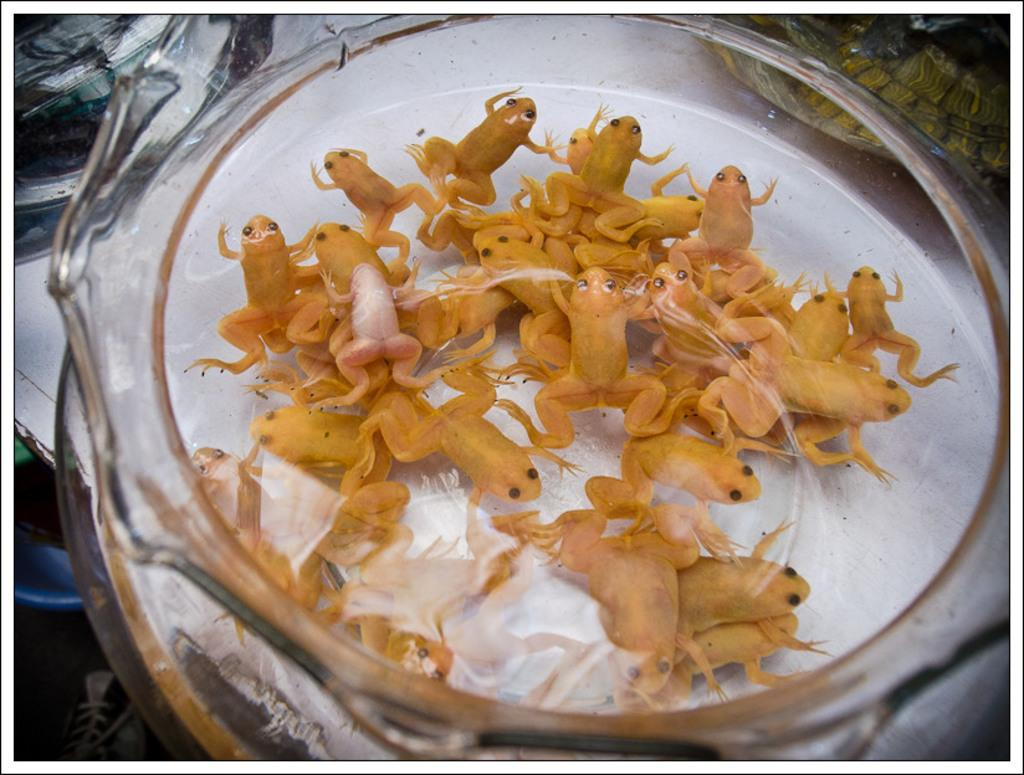What animals are in the glass jar in the image? There are frogs in a glass jar in the image. Where is the glass jar located? The glass jar is on a table in the image. What else can be seen on the table? There are objects on the table in the image. What is visible in the left bottom area of the image? There are objects on the floor in the left bottom area of the image. What type of father can be seen playing with the rabbits in the field in the image? There is no father, rabbits, or field present in the image; it only shows frogs in a glass jar on a table with other objects nearby. 